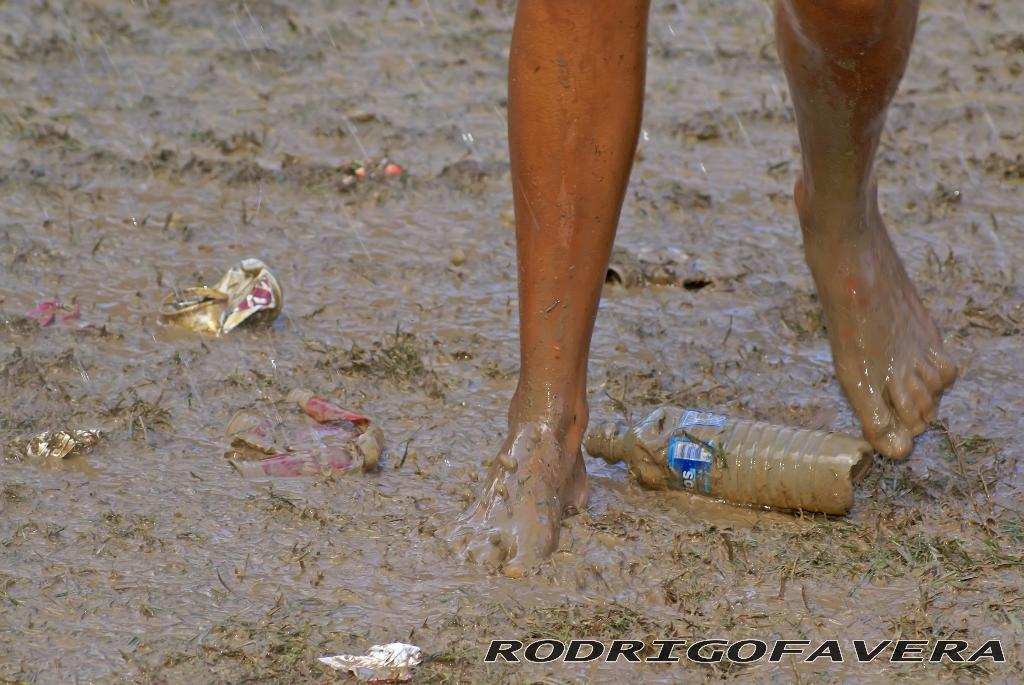What body parts are visible in the image? There are person's legs in the image. How many people are present in the image? There are twins in the image. What is one object present in the image? There is a bottle in the image. What type of items can be seen in the image? There are papers in the image. What is the surface on which the objects are placed? The objects are on mud water. Is there any text visible in the image? Yes, there is some text in the image. How many babies are crawling on the low branch in the image? There are no babies or low branches present in the image. 